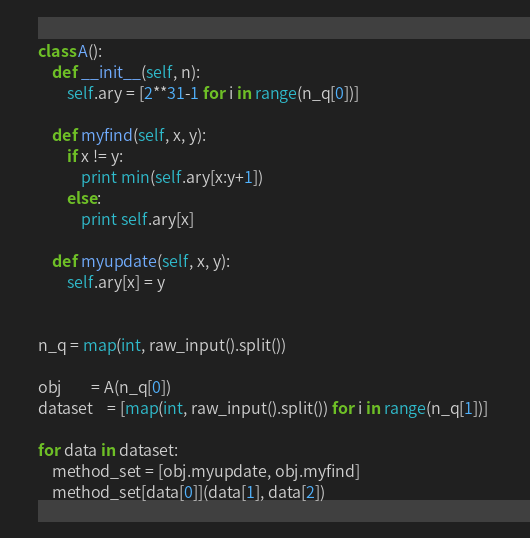<code> <loc_0><loc_0><loc_500><loc_500><_Python_>class A():
	def __init__(self, n):
		self.ary = [2**31-1 for i in range(n_q[0])]
		
	def myfind(self, x, y):
		if x != y:
			print min(self.ary[x:y+1])
		else:
			print self.ary[x]
		
	def myupdate(self, x, y):
		self.ary[x] = y
		
	
n_q = map(int, raw_input().split())

obj		= A(n_q[0])
dataset	= [map(int, raw_input().split()) for i in range(n_q[1])] 

for data in dataset:
	method_set = [obj.myupdate, obj.myfind]
	method_set[data[0]](data[1], data[2])</code> 